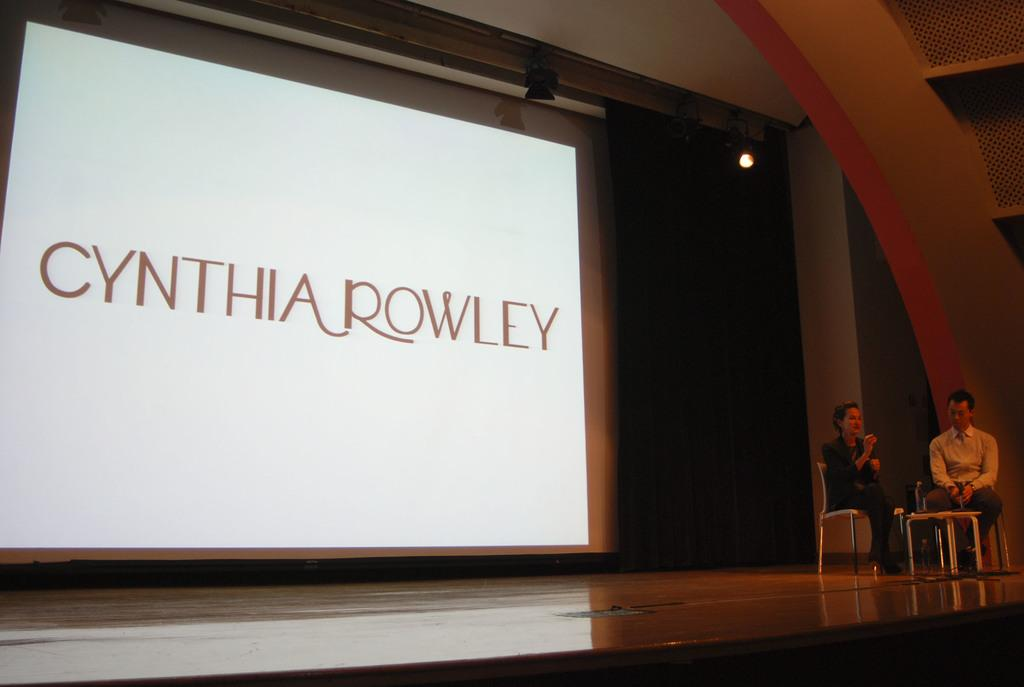How many people are sitting in the image? There are two persons sitting on chairs in the image. What is placed on the floor in the image? A table is placed on the floor in the image. What can be seen on the screen in the background? There is a screen with some text in the background. What else is visible in the background? There are lights visible in the background. What type of education can be seen taking place in the cellar in the image? There is no cellar present in the image, and no education is taking place. 